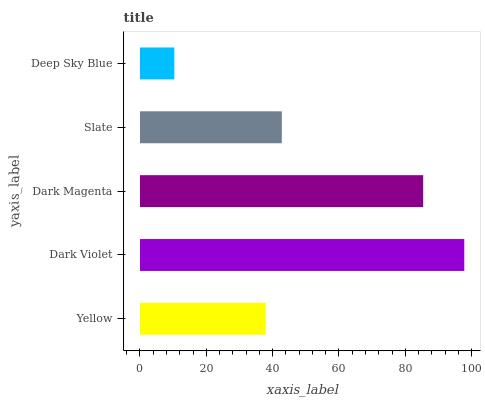Is Deep Sky Blue the minimum?
Answer yes or no. Yes. Is Dark Violet the maximum?
Answer yes or no. Yes. Is Dark Magenta the minimum?
Answer yes or no. No. Is Dark Magenta the maximum?
Answer yes or no. No. Is Dark Violet greater than Dark Magenta?
Answer yes or no. Yes. Is Dark Magenta less than Dark Violet?
Answer yes or no. Yes. Is Dark Magenta greater than Dark Violet?
Answer yes or no. No. Is Dark Violet less than Dark Magenta?
Answer yes or no. No. Is Slate the high median?
Answer yes or no. Yes. Is Slate the low median?
Answer yes or no. Yes. Is Dark Magenta the high median?
Answer yes or no. No. Is Deep Sky Blue the low median?
Answer yes or no. No. 